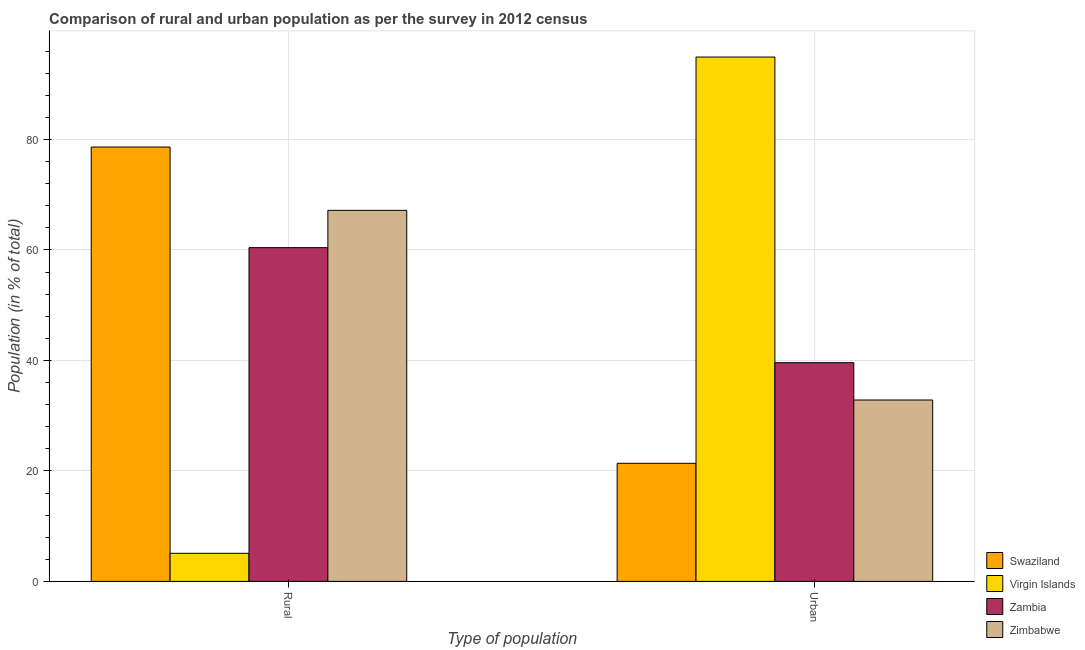Are the number of bars per tick equal to the number of legend labels?
Ensure brevity in your answer.  Yes. Are the number of bars on each tick of the X-axis equal?
Provide a short and direct response. Yes. How many bars are there on the 1st tick from the left?
Your response must be concise. 4. What is the label of the 1st group of bars from the left?
Offer a terse response. Rural. What is the rural population in Virgin Islands?
Ensure brevity in your answer.  5.08. Across all countries, what is the maximum urban population?
Keep it short and to the point. 94.92. Across all countries, what is the minimum urban population?
Make the answer very short. 21.37. In which country was the urban population maximum?
Offer a terse response. Virgin Islands. In which country was the rural population minimum?
Your answer should be compact. Virgin Islands. What is the total rural population in the graph?
Ensure brevity in your answer.  211.29. What is the difference between the urban population in Virgin Islands and that in Zimbabwe?
Your response must be concise. 62.08. What is the difference between the rural population in Swaziland and the urban population in Virgin Islands?
Provide a succinct answer. -16.29. What is the average rural population per country?
Make the answer very short. 52.82. What is the difference between the rural population and urban population in Zambia?
Your answer should be compact. 20.83. In how many countries, is the urban population greater than 4 %?
Offer a terse response. 4. What is the ratio of the rural population in Swaziland to that in Virgin Islands?
Provide a succinct answer. 15.47. In how many countries, is the urban population greater than the average urban population taken over all countries?
Offer a very short reply. 1. What does the 2nd bar from the left in Urban represents?
Your answer should be very brief. Virgin Islands. What does the 4th bar from the right in Urban represents?
Your response must be concise. Swaziland. How many countries are there in the graph?
Provide a succinct answer. 4. What is the difference between two consecutive major ticks on the Y-axis?
Provide a succinct answer. 20. Are the values on the major ticks of Y-axis written in scientific E-notation?
Offer a very short reply. No. How are the legend labels stacked?
Give a very brief answer. Vertical. What is the title of the graph?
Your answer should be compact. Comparison of rural and urban population as per the survey in 2012 census. What is the label or title of the X-axis?
Your answer should be compact. Type of population. What is the label or title of the Y-axis?
Make the answer very short. Population (in % of total). What is the Population (in % of total) of Swaziland in Rural?
Your response must be concise. 78.63. What is the Population (in % of total) in Virgin Islands in Rural?
Provide a short and direct response. 5.08. What is the Population (in % of total) of Zambia in Rural?
Your answer should be very brief. 60.41. What is the Population (in % of total) of Zimbabwe in Rural?
Ensure brevity in your answer.  67.17. What is the Population (in % of total) in Swaziland in Urban?
Keep it short and to the point. 21.37. What is the Population (in % of total) of Virgin Islands in Urban?
Your answer should be compact. 94.92. What is the Population (in % of total) in Zambia in Urban?
Your answer should be compact. 39.59. What is the Population (in % of total) in Zimbabwe in Urban?
Make the answer very short. 32.83. Across all Type of population, what is the maximum Population (in % of total) in Swaziland?
Your answer should be very brief. 78.63. Across all Type of population, what is the maximum Population (in % of total) of Virgin Islands?
Your answer should be compact. 94.92. Across all Type of population, what is the maximum Population (in % of total) of Zambia?
Provide a short and direct response. 60.41. Across all Type of population, what is the maximum Population (in % of total) in Zimbabwe?
Your response must be concise. 67.17. Across all Type of population, what is the minimum Population (in % of total) of Swaziland?
Your answer should be compact. 21.37. Across all Type of population, what is the minimum Population (in % of total) in Virgin Islands?
Keep it short and to the point. 5.08. Across all Type of population, what is the minimum Population (in % of total) of Zambia?
Offer a very short reply. 39.59. Across all Type of population, what is the minimum Population (in % of total) of Zimbabwe?
Your answer should be compact. 32.83. What is the total Population (in % of total) in Swaziland in the graph?
Give a very brief answer. 100. What is the total Population (in % of total) of Zambia in the graph?
Ensure brevity in your answer.  100. What is the total Population (in % of total) of Zimbabwe in the graph?
Ensure brevity in your answer.  100. What is the difference between the Population (in % of total) in Swaziland in Rural and that in Urban?
Your answer should be very brief. 57.25. What is the difference between the Population (in % of total) of Virgin Islands in Rural and that in Urban?
Provide a short and direct response. -89.83. What is the difference between the Population (in % of total) of Zambia in Rural and that in Urban?
Keep it short and to the point. 20.83. What is the difference between the Population (in % of total) of Zimbabwe in Rural and that in Urban?
Keep it short and to the point. 34.33. What is the difference between the Population (in % of total) of Swaziland in Rural and the Population (in % of total) of Virgin Islands in Urban?
Your response must be concise. -16.29. What is the difference between the Population (in % of total) in Swaziland in Rural and the Population (in % of total) in Zambia in Urban?
Provide a short and direct response. 39.04. What is the difference between the Population (in % of total) in Swaziland in Rural and the Population (in % of total) in Zimbabwe in Urban?
Offer a very short reply. 45.79. What is the difference between the Population (in % of total) of Virgin Islands in Rural and the Population (in % of total) of Zambia in Urban?
Your answer should be very brief. -34.5. What is the difference between the Population (in % of total) in Virgin Islands in Rural and the Population (in % of total) in Zimbabwe in Urban?
Offer a very short reply. -27.75. What is the difference between the Population (in % of total) in Zambia in Rural and the Population (in % of total) in Zimbabwe in Urban?
Your response must be concise. 27.58. What is the average Population (in % of total) of Swaziland per Type of population?
Make the answer very short. 50. What is the difference between the Population (in % of total) in Swaziland and Population (in % of total) in Virgin Islands in Rural?
Give a very brief answer. 73.54. What is the difference between the Population (in % of total) of Swaziland and Population (in % of total) of Zambia in Rural?
Make the answer very short. 18.21. What is the difference between the Population (in % of total) of Swaziland and Population (in % of total) of Zimbabwe in Rural?
Ensure brevity in your answer.  11.46. What is the difference between the Population (in % of total) of Virgin Islands and Population (in % of total) of Zambia in Rural?
Your answer should be very brief. -55.33. What is the difference between the Population (in % of total) of Virgin Islands and Population (in % of total) of Zimbabwe in Rural?
Provide a succinct answer. -62.08. What is the difference between the Population (in % of total) in Zambia and Population (in % of total) in Zimbabwe in Rural?
Provide a succinct answer. -6.75. What is the difference between the Population (in % of total) in Swaziland and Population (in % of total) in Virgin Islands in Urban?
Offer a terse response. -73.54. What is the difference between the Population (in % of total) of Swaziland and Population (in % of total) of Zambia in Urban?
Provide a short and direct response. -18.21. What is the difference between the Population (in % of total) in Swaziland and Population (in % of total) in Zimbabwe in Urban?
Your response must be concise. -11.46. What is the difference between the Population (in % of total) of Virgin Islands and Population (in % of total) of Zambia in Urban?
Your response must be concise. 55.33. What is the difference between the Population (in % of total) of Virgin Islands and Population (in % of total) of Zimbabwe in Urban?
Make the answer very short. 62.08. What is the difference between the Population (in % of total) of Zambia and Population (in % of total) of Zimbabwe in Urban?
Provide a succinct answer. 6.75. What is the ratio of the Population (in % of total) of Swaziland in Rural to that in Urban?
Your response must be concise. 3.68. What is the ratio of the Population (in % of total) of Virgin Islands in Rural to that in Urban?
Your answer should be compact. 0.05. What is the ratio of the Population (in % of total) in Zambia in Rural to that in Urban?
Give a very brief answer. 1.53. What is the ratio of the Population (in % of total) of Zimbabwe in Rural to that in Urban?
Give a very brief answer. 2.05. What is the difference between the highest and the second highest Population (in % of total) in Swaziland?
Your response must be concise. 57.25. What is the difference between the highest and the second highest Population (in % of total) in Virgin Islands?
Offer a very short reply. 89.83. What is the difference between the highest and the second highest Population (in % of total) of Zambia?
Offer a terse response. 20.83. What is the difference between the highest and the second highest Population (in % of total) in Zimbabwe?
Give a very brief answer. 34.33. What is the difference between the highest and the lowest Population (in % of total) in Swaziland?
Provide a short and direct response. 57.25. What is the difference between the highest and the lowest Population (in % of total) in Virgin Islands?
Provide a short and direct response. 89.83. What is the difference between the highest and the lowest Population (in % of total) in Zambia?
Your answer should be compact. 20.83. What is the difference between the highest and the lowest Population (in % of total) of Zimbabwe?
Offer a terse response. 34.33. 